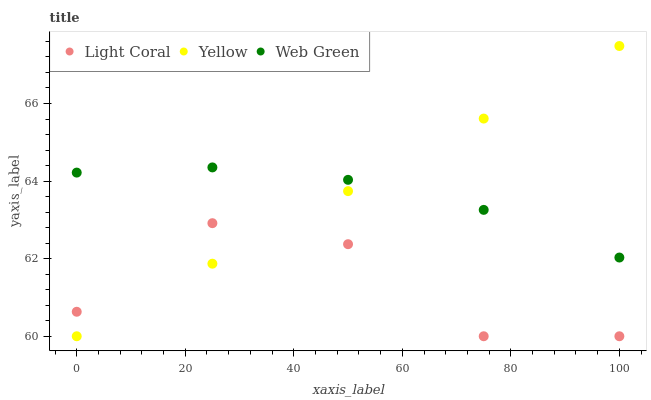Does Light Coral have the minimum area under the curve?
Answer yes or no. Yes. Does Yellow have the maximum area under the curve?
Answer yes or no. Yes. Does Web Green have the minimum area under the curve?
Answer yes or no. No. Does Web Green have the maximum area under the curve?
Answer yes or no. No. Is Yellow the smoothest?
Answer yes or no. Yes. Is Light Coral the roughest?
Answer yes or no. Yes. Is Web Green the smoothest?
Answer yes or no. No. Is Web Green the roughest?
Answer yes or no. No. Does Light Coral have the lowest value?
Answer yes or no. Yes. Does Web Green have the lowest value?
Answer yes or no. No. Does Yellow have the highest value?
Answer yes or no. Yes. Does Web Green have the highest value?
Answer yes or no. No. Is Light Coral less than Web Green?
Answer yes or no. Yes. Is Web Green greater than Light Coral?
Answer yes or no. Yes. Does Light Coral intersect Yellow?
Answer yes or no. Yes. Is Light Coral less than Yellow?
Answer yes or no. No. Is Light Coral greater than Yellow?
Answer yes or no. No. Does Light Coral intersect Web Green?
Answer yes or no. No. 